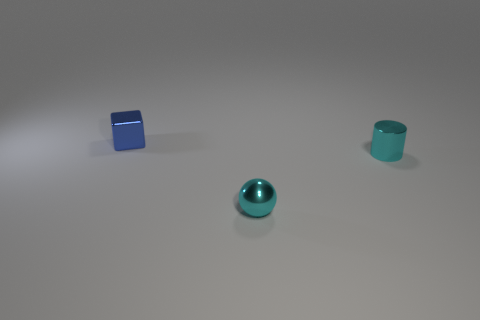Add 3 shiny cubes. How many objects exist? 6 Subtract all spheres. How many objects are left? 2 Subtract 1 cyan cylinders. How many objects are left? 2 Subtract all purple cylinders. Subtract all cyan cubes. How many cylinders are left? 1 Subtract all shiny objects. Subtract all gray metal spheres. How many objects are left? 0 Add 1 tiny blue cubes. How many tiny blue cubes are left? 2 Add 1 small blue metallic things. How many small blue metallic things exist? 2 